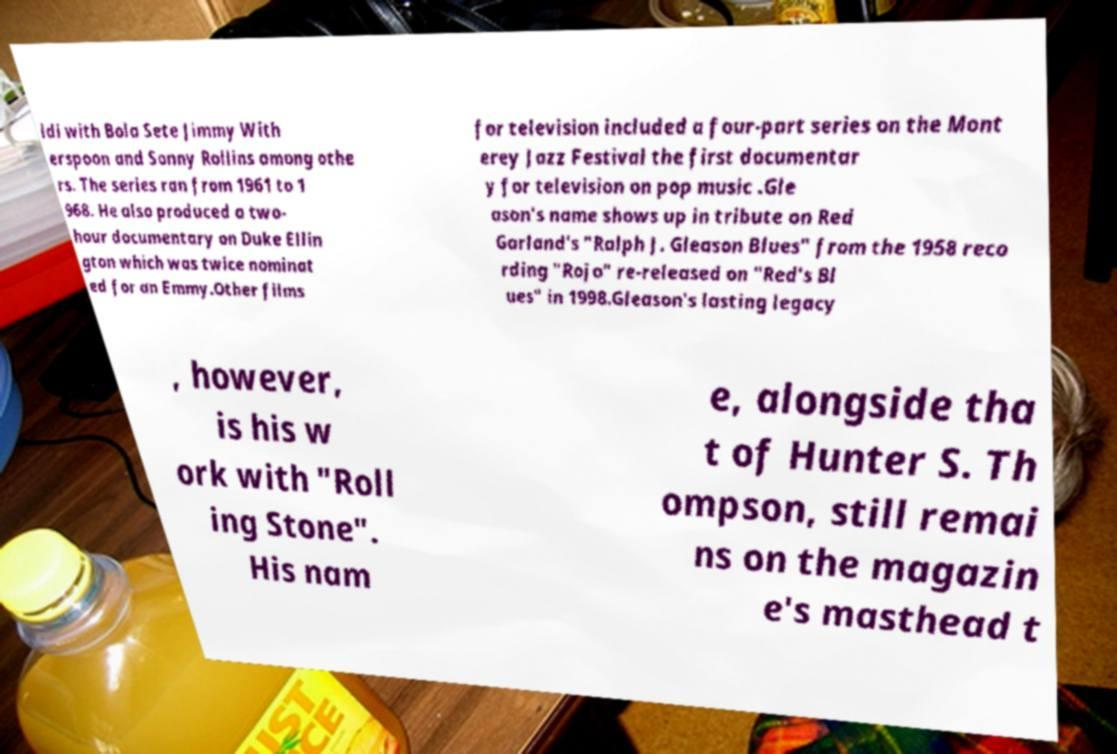I need the written content from this picture converted into text. Can you do that? ldi with Bola Sete Jimmy With erspoon and Sonny Rollins among othe rs. The series ran from 1961 to 1 968. He also produced a two- hour documentary on Duke Ellin gton which was twice nominat ed for an Emmy.Other films for television included a four-part series on the Mont erey Jazz Festival the first documentar y for television on pop music .Gle ason's name shows up in tribute on Red Garland's "Ralph J. Gleason Blues" from the 1958 reco rding "Rojo" re-released on "Red's Bl ues" in 1998.Gleason's lasting legacy , however, is his w ork with "Roll ing Stone". His nam e, alongside tha t of Hunter S. Th ompson, still remai ns on the magazin e's masthead t 